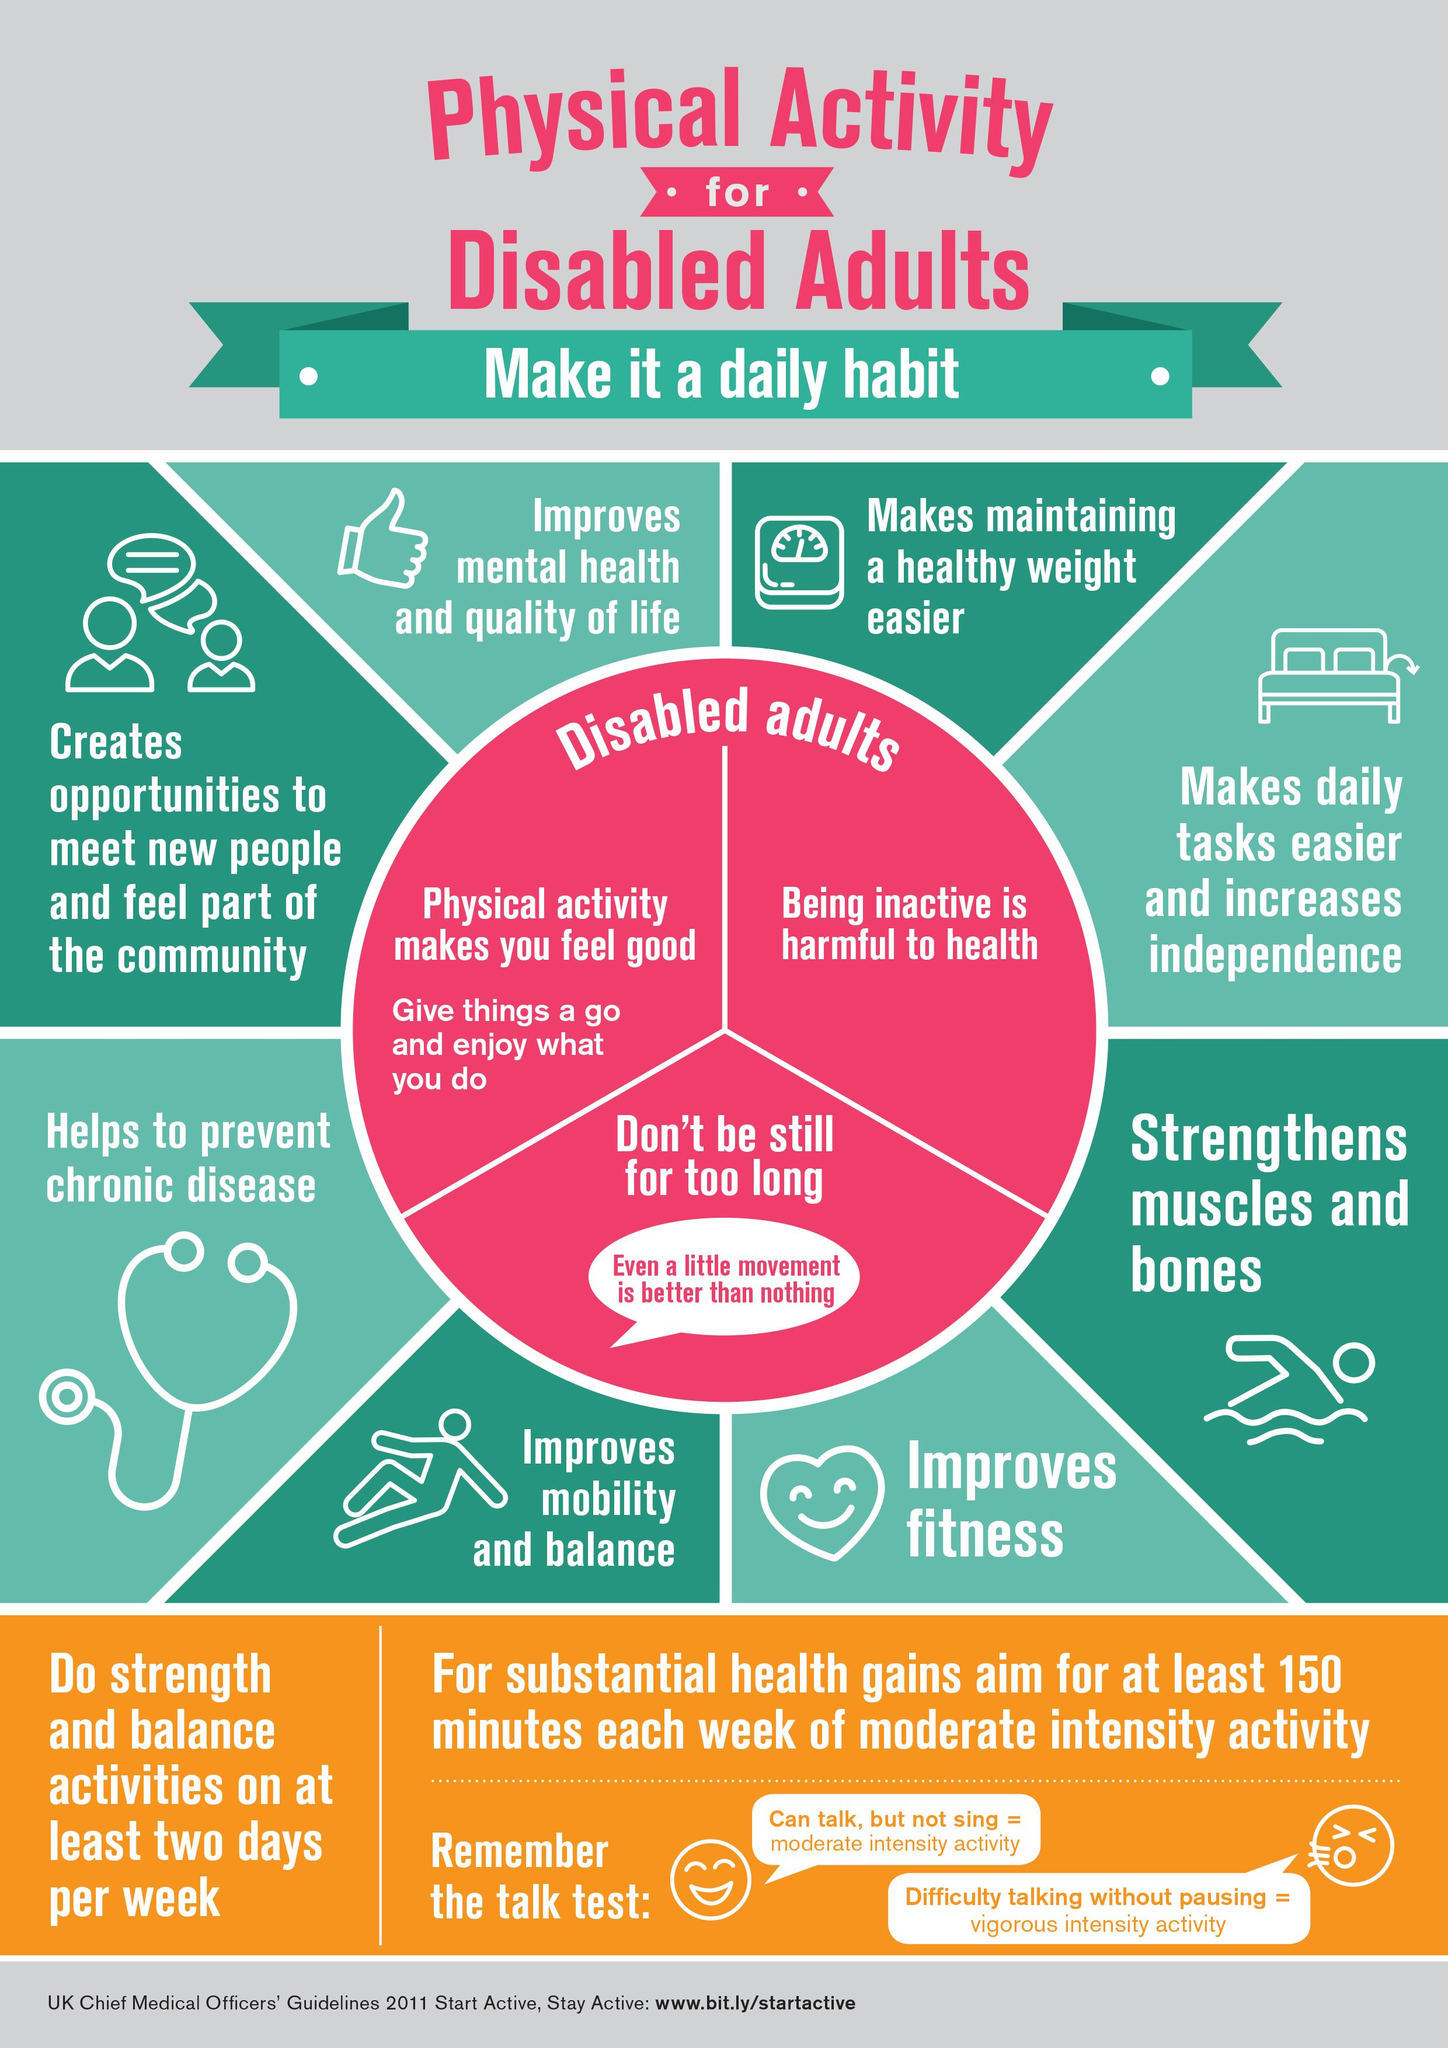Specify some key components in this picture. Physical activity is known to improve mental health and enhance quality of life. It is recommended that individuals engage in moderate intensity activity for a minimum of 150 minutes per week in order to achieve overall health benefits. I believe that physical activity is what makes me feel good. It is recommended to engage in activities that focus on both strength and balance for a period of two days per week. Being inactive is harmful to one's health. 